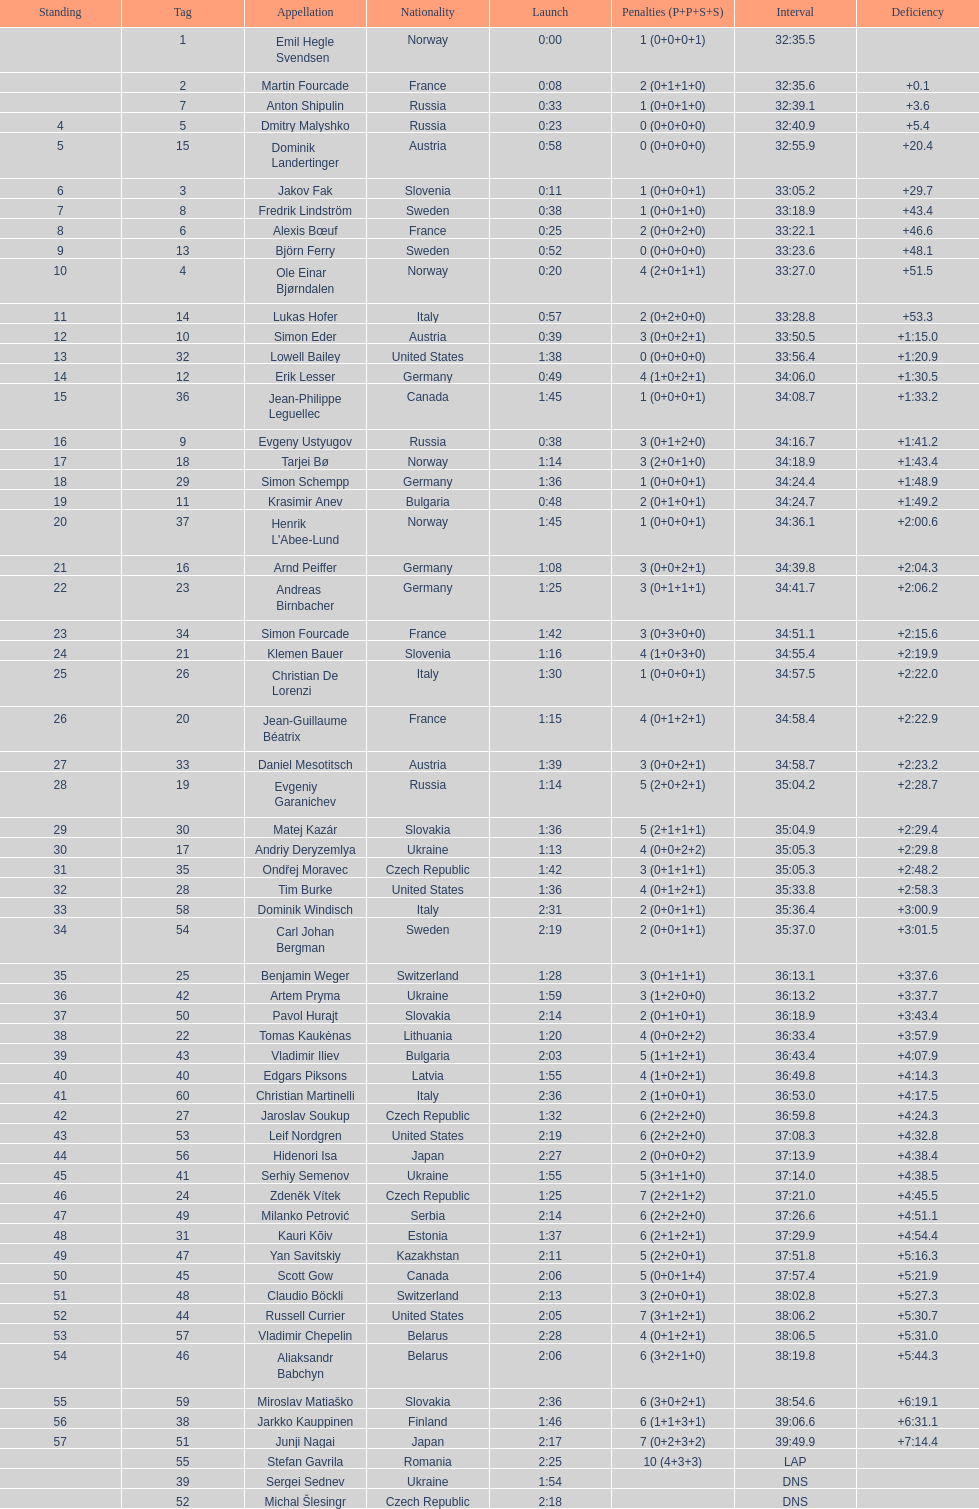What is the largest penalty? 10. 